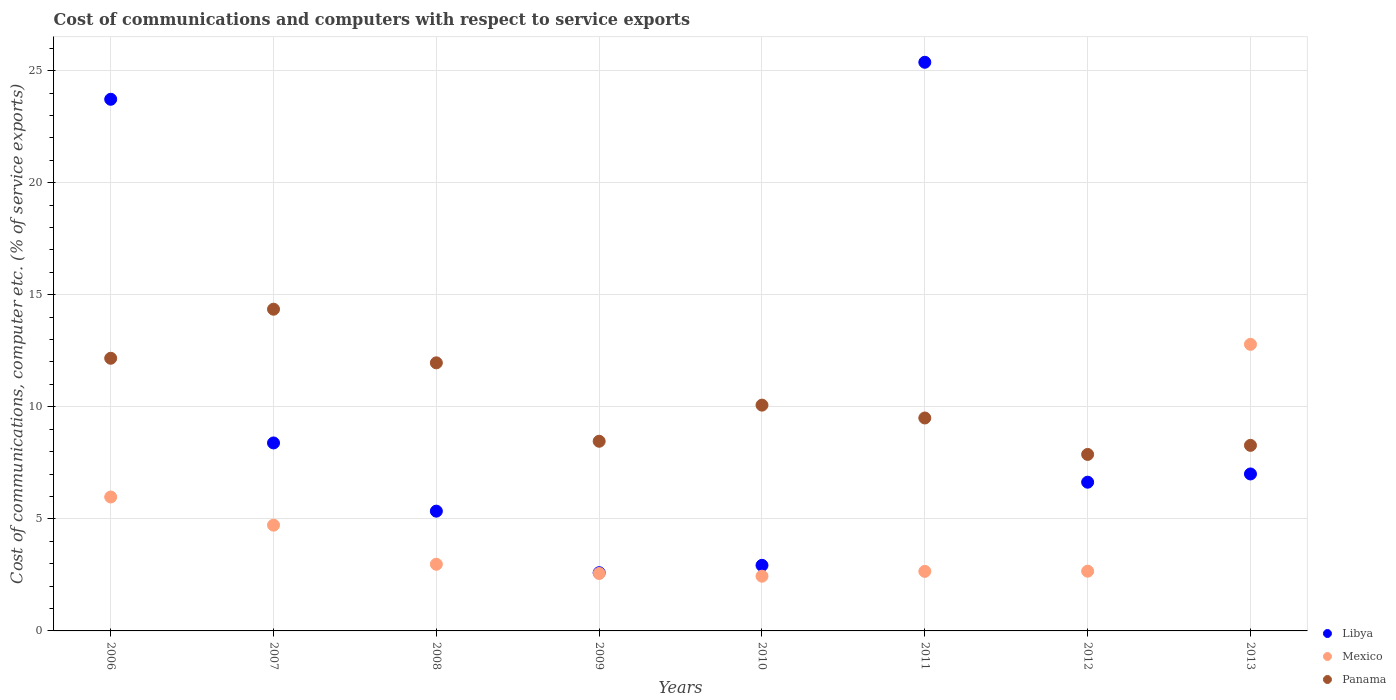Is the number of dotlines equal to the number of legend labels?
Offer a terse response. Yes. What is the cost of communications and computers in Libya in 2008?
Your answer should be compact. 5.34. Across all years, what is the maximum cost of communications and computers in Mexico?
Offer a terse response. 12.79. Across all years, what is the minimum cost of communications and computers in Mexico?
Offer a very short reply. 2.44. In which year was the cost of communications and computers in Libya maximum?
Ensure brevity in your answer.  2011. In which year was the cost of communications and computers in Libya minimum?
Provide a succinct answer. 2009. What is the total cost of communications and computers in Panama in the graph?
Make the answer very short. 82.68. What is the difference between the cost of communications and computers in Mexico in 2006 and that in 2013?
Give a very brief answer. -6.81. What is the difference between the cost of communications and computers in Mexico in 2011 and the cost of communications and computers in Panama in 2013?
Your answer should be compact. -5.62. What is the average cost of communications and computers in Libya per year?
Give a very brief answer. 10.25. In the year 2012, what is the difference between the cost of communications and computers in Mexico and cost of communications and computers in Libya?
Give a very brief answer. -3.97. What is the ratio of the cost of communications and computers in Mexico in 2009 to that in 2011?
Ensure brevity in your answer.  0.96. Is the cost of communications and computers in Mexico in 2010 less than that in 2013?
Your response must be concise. Yes. What is the difference between the highest and the second highest cost of communications and computers in Panama?
Your answer should be compact. 2.19. What is the difference between the highest and the lowest cost of communications and computers in Mexico?
Ensure brevity in your answer.  10.35. In how many years, is the cost of communications and computers in Libya greater than the average cost of communications and computers in Libya taken over all years?
Your answer should be compact. 2. Does the cost of communications and computers in Panama monotonically increase over the years?
Provide a succinct answer. No. Is the cost of communications and computers in Mexico strictly greater than the cost of communications and computers in Panama over the years?
Offer a terse response. No. Is the cost of communications and computers in Panama strictly less than the cost of communications and computers in Libya over the years?
Give a very brief answer. No. How many years are there in the graph?
Ensure brevity in your answer.  8. What is the difference between two consecutive major ticks on the Y-axis?
Offer a very short reply. 5. Are the values on the major ticks of Y-axis written in scientific E-notation?
Ensure brevity in your answer.  No. How many legend labels are there?
Your answer should be compact. 3. How are the legend labels stacked?
Provide a succinct answer. Vertical. What is the title of the graph?
Provide a short and direct response. Cost of communications and computers with respect to service exports. What is the label or title of the X-axis?
Your answer should be compact. Years. What is the label or title of the Y-axis?
Offer a terse response. Cost of communications, computer etc. (% of service exports). What is the Cost of communications, computer etc. (% of service exports) in Libya in 2006?
Ensure brevity in your answer.  23.72. What is the Cost of communications, computer etc. (% of service exports) of Mexico in 2006?
Give a very brief answer. 5.98. What is the Cost of communications, computer etc. (% of service exports) of Panama in 2006?
Your answer should be very brief. 12.17. What is the Cost of communications, computer etc. (% of service exports) in Libya in 2007?
Your response must be concise. 8.39. What is the Cost of communications, computer etc. (% of service exports) of Mexico in 2007?
Give a very brief answer. 4.72. What is the Cost of communications, computer etc. (% of service exports) of Panama in 2007?
Your response must be concise. 14.35. What is the Cost of communications, computer etc. (% of service exports) in Libya in 2008?
Provide a short and direct response. 5.34. What is the Cost of communications, computer etc. (% of service exports) of Mexico in 2008?
Offer a very short reply. 2.97. What is the Cost of communications, computer etc. (% of service exports) of Panama in 2008?
Offer a terse response. 11.96. What is the Cost of communications, computer etc. (% of service exports) of Libya in 2009?
Provide a short and direct response. 2.6. What is the Cost of communications, computer etc. (% of service exports) of Mexico in 2009?
Ensure brevity in your answer.  2.56. What is the Cost of communications, computer etc. (% of service exports) of Panama in 2009?
Your response must be concise. 8.46. What is the Cost of communications, computer etc. (% of service exports) of Libya in 2010?
Your response must be concise. 2.93. What is the Cost of communications, computer etc. (% of service exports) of Mexico in 2010?
Keep it short and to the point. 2.44. What is the Cost of communications, computer etc. (% of service exports) in Panama in 2010?
Your answer should be very brief. 10.07. What is the Cost of communications, computer etc. (% of service exports) of Libya in 2011?
Provide a succinct answer. 25.37. What is the Cost of communications, computer etc. (% of service exports) in Mexico in 2011?
Make the answer very short. 2.66. What is the Cost of communications, computer etc. (% of service exports) of Panama in 2011?
Make the answer very short. 9.5. What is the Cost of communications, computer etc. (% of service exports) in Libya in 2012?
Your answer should be very brief. 6.64. What is the Cost of communications, computer etc. (% of service exports) of Mexico in 2012?
Give a very brief answer. 2.67. What is the Cost of communications, computer etc. (% of service exports) of Panama in 2012?
Your answer should be compact. 7.87. What is the Cost of communications, computer etc. (% of service exports) in Libya in 2013?
Give a very brief answer. 7. What is the Cost of communications, computer etc. (% of service exports) of Mexico in 2013?
Your answer should be compact. 12.79. What is the Cost of communications, computer etc. (% of service exports) in Panama in 2013?
Give a very brief answer. 8.28. Across all years, what is the maximum Cost of communications, computer etc. (% of service exports) of Libya?
Your answer should be compact. 25.37. Across all years, what is the maximum Cost of communications, computer etc. (% of service exports) of Mexico?
Your answer should be very brief. 12.79. Across all years, what is the maximum Cost of communications, computer etc. (% of service exports) of Panama?
Provide a succinct answer. 14.35. Across all years, what is the minimum Cost of communications, computer etc. (% of service exports) of Libya?
Your answer should be very brief. 2.6. Across all years, what is the minimum Cost of communications, computer etc. (% of service exports) in Mexico?
Provide a succinct answer. 2.44. Across all years, what is the minimum Cost of communications, computer etc. (% of service exports) of Panama?
Offer a terse response. 7.87. What is the total Cost of communications, computer etc. (% of service exports) in Libya in the graph?
Your response must be concise. 81.99. What is the total Cost of communications, computer etc. (% of service exports) in Mexico in the graph?
Ensure brevity in your answer.  36.78. What is the total Cost of communications, computer etc. (% of service exports) of Panama in the graph?
Make the answer very short. 82.68. What is the difference between the Cost of communications, computer etc. (% of service exports) of Libya in 2006 and that in 2007?
Ensure brevity in your answer.  15.33. What is the difference between the Cost of communications, computer etc. (% of service exports) of Mexico in 2006 and that in 2007?
Provide a succinct answer. 1.26. What is the difference between the Cost of communications, computer etc. (% of service exports) of Panama in 2006 and that in 2007?
Offer a very short reply. -2.19. What is the difference between the Cost of communications, computer etc. (% of service exports) in Libya in 2006 and that in 2008?
Give a very brief answer. 18.38. What is the difference between the Cost of communications, computer etc. (% of service exports) of Mexico in 2006 and that in 2008?
Keep it short and to the point. 3. What is the difference between the Cost of communications, computer etc. (% of service exports) of Panama in 2006 and that in 2008?
Make the answer very short. 0.2. What is the difference between the Cost of communications, computer etc. (% of service exports) in Libya in 2006 and that in 2009?
Offer a very short reply. 21.12. What is the difference between the Cost of communications, computer etc. (% of service exports) of Mexico in 2006 and that in 2009?
Give a very brief answer. 3.41. What is the difference between the Cost of communications, computer etc. (% of service exports) of Panama in 2006 and that in 2009?
Provide a short and direct response. 3.7. What is the difference between the Cost of communications, computer etc. (% of service exports) of Libya in 2006 and that in 2010?
Provide a short and direct response. 20.8. What is the difference between the Cost of communications, computer etc. (% of service exports) in Mexico in 2006 and that in 2010?
Give a very brief answer. 3.53. What is the difference between the Cost of communications, computer etc. (% of service exports) in Panama in 2006 and that in 2010?
Your response must be concise. 2.09. What is the difference between the Cost of communications, computer etc. (% of service exports) in Libya in 2006 and that in 2011?
Your response must be concise. -1.65. What is the difference between the Cost of communications, computer etc. (% of service exports) in Mexico in 2006 and that in 2011?
Give a very brief answer. 3.32. What is the difference between the Cost of communications, computer etc. (% of service exports) in Panama in 2006 and that in 2011?
Offer a terse response. 2.66. What is the difference between the Cost of communications, computer etc. (% of service exports) in Libya in 2006 and that in 2012?
Ensure brevity in your answer.  17.09. What is the difference between the Cost of communications, computer etc. (% of service exports) of Mexico in 2006 and that in 2012?
Offer a terse response. 3.31. What is the difference between the Cost of communications, computer etc. (% of service exports) of Panama in 2006 and that in 2012?
Keep it short and to the point. 4.29. What is the difference between the Cost of communications, computer etc. (% of service exports) in Libya in 2006 and that in 2013?
Offer a terse response. 16.72. What is the difference between the Cost of communications, computer etc. (% of service exports) in Mexico in 2006 and that in 2013?
Ensure brevity in your answer.  -6.81. What is the difference between the Cost of communications, computer etc. (% of service exports) of Panama in 2006 and that in 2013?
Offer a terse response. 3.89. What is the difference between the Cost of communications, computer etc. (% of service exports) in Libya in 2007 and that in 2008?
Make the answer very short. 3.04. What is the difference between the Cost of communications, computer etc. (% of service exports) in Mexico in 2007 and that in 2008?
Provide a short and direct response. 1.75. What is the difference between the Cost of communications, computer etc. (% of service exports) of Panama in 2007 and that in 2008?
Provide a short and direct response. 2.39. What is the difference between the Cost of communications, computer etc. (% of service exports) of Libya in 2007 and that in 2009?
Provide a succinct answer. 5.79. What is the difference between the Cost of communications, computer etc. (% of service exports) of Mexico in 2007 and that in 2009?
Provide a succinct answer. 2.16. What is the difference between the Cost of communications, computer etc. (% of service exports) of Panama in 2007 and that in 2009?
Your response must be concise. 5.89. What is the difference between the Cost of communications, computer etc. (% of service exports) of Libya in 2007 and that in 2010?
Your response must be concise. 5.46. What is the difference between the Cost of communications, computer etc. (% of service exports) of Mexico in 2007 and that in 2010?
Provide a short and direct response. 2.28. What is the difference between the Cost of communications, computer etc. (% of service exports) in Panama in 2007 and that in 2010?
Provide a succinct answer. 4.28. What is the difference between the Cost of communications, computer etc. (% of service exports) of Libya in 2007 and that in 2011?
Provide a short and direct response. -16.99. What is the difference between the Cost of communications, computer etc. (% of service exports) in Mexico in 2007 and that in 2011?
Keep it short and to the point. 2.06. What is the difference between the Cost of communications, computer etc. (% of service exports) of Panama in 2007 and that in 2011?
Your answer should be very brief. 4.85. What is the difference between the Cost of communications, computer etc. (% of service exports) in Libya in 2007 and that in 2012?
Offer a terse response. 1.75. What is the difference between the Cost of communications, computer etc. (% of service exports) of Mexico in 2007 and that in 2012?
Offer a terse response. 2.05. What is the difference between the Cost of communications, computer etc. (% of service exports) of Panama in 2007 and that in 2012?
Provide a short and direct response. 6.48. What is the difference between the Cost of communications, computer etc. (% of service exports) of Libya in 2007 and that in 2013?
Keep it short and to the point. 1.38. What is the difference between the Cost of communications, computer etc. (% of service exports) of Mexico in 2007 and that in 2013?
Offer a very short reply. -8.07. What is the difference between the Cost of communications, computer etc. (% of service exports) in Panama in 2007 and that in 2013?
Ensure brevity in your answer.  6.07. What is the difference between the Cost of communications, computer etc. (% of service exports) in Libya in 2008 and that in 2009?
Your response must be concise. 2.75. What is the difference between the Cost of communications, computer etc. (% of service exports) in Mexico in 2008 and that in 2009?
Your response must be concise. 0.41. What is the difference between the Cost of communications, computer etc. (% of service exports) of Panama in 2008 and that in 2009?
Provide a succinct answer. 3.5. What is the difference between the Cost of communications, computer etc. (% of service exports) of Libya in 2008 and that in 2010?
Keep it short and to the point. 2.42. What is the difference between the Cost of communications, computer etc. (% of service exports) in Mexico in 2008 and that in 2010?
Make the answer very short. 0.53. What is the difference between the Cost of communications, computer etc. (% of service exports) in Panama in 2008 and that in 2010?
Make the answer very short. 1.89. What is the difference between the Cost of communications, computer etc. (% of service exports) of Libya in 2008 and that in 2011?
Your response must be concise. -20.03. What is the difference between the Cost of communications, computer etc. (% of service exports) of Mexico in 2008 and that in 2011?
Your answer should be compact. 0.32. What is the difference between the Cost of communications, computer etc. (% of service exports) of Panama in 2008 and that in 2011?
Provide a short and direct response. 2.46. What is the difference between the Cost of communications, computer etc. (% of service exports) of Libya in 2008 and that in 2012?
Your answer should be very brief. -1.29. What is the difference between the Cost of communications, computer etc. (% of service exports) in Mexico in 2008 and that in 2012?
Keep it short and to the point. 0.31. What is the difference between the Cost of communications, computer etc. (% of service exports) in Panama in 2008 and that in 2012?
Provide a succinct answer. 4.09. What is the difference between the Cost of communications, computer etc. (% of service exports) of Libya in 2008 and that in 2013?
Your response must be concise. -1.66. What is the difference between the Cost of communications, computer etc. (% of service exports) in Mexico in 2008 and that in 2013?
Your response must be concise. -9.81. What is the difference between the Cost of communications, computer etc. (% of service exports) in Panama in 2008 and that in 2013?
Provide a short and direct response. 3.68. What is the difference between the Cost of communications, computer etc. (% of service exports) in Libya in 2009 and that in 2010?
Your answer should be very brief. -0.33. What is the difference between the Cost of communications, computer etc. (% of service exports) in Mexico in 2009 and that in 2010?
Make the answer very short. 0.12. What is the difference between the Cost of communications, computer etc. (% of service exports) of Panama in 2009 and that in 2010?
Your answer should be compact. -1.61. What is the difference between the Cost of communications, computer etc. (% of service exports) in Libya in 2009 and that in 2011?
Provide a short and direct response. -22.78. What is the difference between the Cost of communications, computer etc. (% of service exports) of Mexico in 2009 and that in 2011?
Provide a succinct answer. -0.09. What is the difference between the Cost of communications, computer etc. (% of service exports) of Panama in 2009 and that in 2011?
Make the answer very short. -1.04. What is the difference between the Cost of communications, computer etc. (% of service exports) in Libya in 2009 and that in 2012?
Your answer should be very brief. -4.04. What is the difference between the Cost of communications, computer etc. (% of service exports) of Mexico in 2009 and that in 2012?
Your answer should be compact. -0.1. What is the difference between the Cost of communications, computer etc. (% of service exports) in Panama in 2009 and that in 2012?
Ensure brevity in your answer.  0.59. What is the difference between the Cost of communications, computer etc. (% of service exports) of Libya in 2009 and that in 2013?
Your answer should be compact. -4.41. What is the difference between the Cost of communications, computer etc. (% of service exports) of Mexico in 2009 and that in 2013?
Your response must be concise. -10.22. What is the difference between the Cost of communications, computer etc. (% of service exports) of Panama in 2009 and that in 2013?
Keep it short and to the point. 0.18. What is the difference between the Cost of communications, computer etc. (% of service exports) of Libya in 2010 and that in 2011?
Provide a short and direct response. -22.45. What is the difference between the Cost of communications, computer etc. (% of service exports) of Mexico in 2010 and that in 2011?
Provide a short and direct response. -0.22. What is the difference between the Cost of communications, computer etc. (% of service exports) of Panama in 2010 and that in 2011?
Provide a succinct answer. 0.57. What is the difference between the Cost of communications, computer etc. (% of service exports) of Libya in 2010 and that in 2012?
Give a very brief answer. -3.71. What is the difference between the Cost of communications, computer etc. (% of service exports) in Mexico in 2010 and that in 2012?
Keep it short and to the point. -0.22. What is the difference between the Cost of communications, computer etc. (% of service exports) in Panama in 2010 and that in 2012?
Offer a very short reply. 2.2. What is the difference between the Cost of communications, computer etc. (% of service exports) in Libya in 2010 and that in 2013?
Provide a short and direct response. -4.08. What is the difference between the Cost of communications, computer etc. (% of service exports) in Mexico in 2010 and that in 2013?
Offer a very short reply. -10.35. What is the difference between the Cost of communications, computer etc. (% of service exports) of Panama in 2010 and that in 2013?
Offer a terse response. 1.8. What is the difference between the Cost of communications, computer etc. (% of service exports) of Libya in 2011 and that in 2012?
Provide a succinct answer. 18.74. What is the difference between the Cost of communications, computer etc. (% of service exports) in Mexico in 2011 and that in 2012?
Give a very brief answer. -0.01. What is the difference between the Cost of communications, computer etc. (% of service exports) in Panama in 2011 and that in 2012?
Offer a terse response. 1.63. What is the difference between the Cost of communications, computer etc. (% of service exports) of Libya in 2011 and that in 2013?
Your answer should be very brief. 18.37. What is the difference between the Cost of communications, computer etc. (% of service exports) of Mexico in 2011 and that in 2013?
Provide a short and direct response. -10.13. What is the difference between the Cost of communications, computer etc. (% of service exports) of Panama in 2011 and that in 2013?
Your answer should be compact. 1.22. What is the difference between the Cost of communications, computer etc. (% of service exports) in Libya in 2012 and that in 2013?
Your answer should be compact. -0.37. What is the difference between the Cost of communications, computer etc. (% of service exports) of Mexico in 2012 and that in 2013?
Give a very brief answer. -10.12. What is the difference between the Cost of communications, computer etc. (% of service exports) in Panama in 2012 and that in 2013?
Provide a short and direct response. -0.4. What is the difference between the Cost of communications, computer etc. (% of service exports) of Libya in 2006 and the Cost of communications, computer etc. (% of service exports) of Mexico in 2007?
Give a very brief answer. 19. What is the difference between the Cost of communications, computer etc. (% of service exports) of Libya in 2006 and the Cost of communications, computer etc. (% of service exports) of Panama in 2007?
Give a very brief answer. 9.37. What is the difference between the Cost of communications, computer etc. (% of service exports) of Mexico in 2006 and the Cost of communications, computer etc. (% of service exports) of Panama in 2007?
Provide a succinct answer. -8.38. What is the difference between the Cost of communications, computer etc. (% of service exports) of Libya in 2006 and the Cost of communications, computer etc. (% of service exports) of Mexico in 2008?
Your answer should be very brief. 20.75. What is the difference between the Cost of communications, computer etc. (% of service exports) of Libya in 2006 and the Cost of communications, computer etc. (% of service exports) of Panama in 2008?
Offer a terse response. 11.76. What is the difference between the Cost of communications, computer etc. (% of service exports) of Mexico in 2006 and the Cost of communications, computer etc. (% of service exports) of Panama in 2008?
Give a very brief answer. -5.99. What is the difference between the Cost of communications, computer etc. (% of service exports) of Libya in 2006 and the Cost of communications, computer etc. (% of service exports) of Mexico in 2009?
Offer a very short reply. 21.16. What is the difference between the Cost of communications, computer etc. (% of service exports) of Libya in 2006 and the Cost of communications, computer etc. (% of service exports) of Panama in 2009?
Your answer should be very brief. 15.26. What is the difference between the Cost of communications, computer etc. (% of service exports) in Mexico in 2006 and the Cost of communications, computer etc. (% of service exports) in Panama in 2009?
Provide a short and direct response. -2.49. What is the difference between the Cost of communications, computer etc. (% of service exports) of Libya in 2006 and the Cost of communications, computer etc. (% of service exports) of Mexico in 2010?
Offer a terse response. 21.28. What is the difference between the Cost of communications, computer etc. (% of service exports) in Libya in 2006 and the Cost of communications, computer etc. (% of service exports) in Panama in 2010?
Offer a very short reply. 13.65. What is the difference between the Cost of communications, computer etc. (% of service exports) in Mexico in 2006 and the Cost of communications, computer etc. (% of service exports) in Panama in 2010?
Offer a terse response. -4.1. What is the difference between the Cost of communications, computer etc. (% of service exports) of Libya in 2006 and the Cost of communications, computer etc. (% of service exports) of Mexico in 2011?
Offer a very short reply. 21.06. What is the difference between the Cost of communications, computer etc. (% of service exports) in Libya in 2006 and the Cost of communications, computer etc. (% of service exports) in Panama in 2011?
Provide a short and direct response. 14.22. What is the difference between the Cost of communications, computer etc. (% of service exports) of Mexico in 2006 and the Cost of communications, computer etc. (% of service exports) of Panama in 2011?
Provide a succinct answer. -3.53. What is the difference between the Cost of communications, computer etc. (% of service exports) in Libya in 2006 and the Cost of communications, computer etc. (% of service exports) in Mexico in 2012?
Your response must be concise. 21.06. What is the difference between the Cost of communications, computer etc. (% of service exports) of Libya in 2006 and the Cost of communications, computer etc. (% of service exports) of Panama in 2012?
Offer a terse response. 15.85. What is the difference between the Cost of communications, computer etc. (% of service exports) of Mexico in 2006 and the Cost of communications, computer etc. (% of service exports) of Panama in 2012?
Ensure brevity in your answer.  -1.9. What is the difference between the Cost of communications, computer etc. (% of service exports) of Libya in 2006 and the Cost of communications, computer etc. (% of service exports) of Mexico in 2013?
Provide a short and direct response. 10.93. What is the difference between the Cost of communications, computer etc. (% of service exports) in Libya in 2006 and the Cost of communications, computer etc. (% of service exports) in Panama in 2013?
Provide a short and direct response. 15.44. What is the difference between the Cost of communications, computer etc. (% of service exports) in Mexico in 2006 and the Cost of communications, computer etc. (% of service exports) in Panama in 2013?
Your answer should be compact. -2.3. What is the difference between the Cost of communications, computer etc. (% of service exports) in Libya in 2007 and the Cost of communications, computer etc. (% of service exports) in Mexico in 2008?
Offer a very short reply. 5.41. What is the difference between the Cost of communications, computer etc. (% of service exports) of Libya in 2007 and the Cost of communications, computer etc. (% of service exports) of Panama in 2008?
Keep it short and to the point. -3.58. What is the difference between the Cost of communications, computer etc. (% of service exports) of Mexico in 2007 and the Cost of communications, computer etc. (% of service exports) of Panama in 2008?
Offer a very short reply. -7.24. What is the difference between the Cost of communications, computer etc. (% of service exports) of Libya in 2007 and the Cost of communications, computer etc. (% of service exports) of Mexico in 2009?
Provide a succinct answer. 5.82. What is the difference between the Cost of communications, computer etc. (% of service exports) of Libya in 2007 and the Cost of communications, computer etc. (% of service exports) of Panama in 2009?
Your response must be concise. -0.08. What is the difference between the Cost of communications, computer etc. (% of service exports) in Mexico in 2007 and the Cost of communications, computer etc. (% of service exports) in Panama in 2009?
Offer a terse response. -3.74. What is the difference between the Cost of communications, computer etc. (% of service exports) of Libya in 2007 and the Cost of communications, computer etc. (% of service exports) of Mexico in 2010?
Offer a very short reply. 5.95. What is the difference between the Cost of communications, computer etc. (% of service exports) of Libya in 2007 and the Cost of communications, computer etc. (% of service exports) of Panama in 2010?
Make the answer very short. -1.69. What is the difference between the Cost of communications, computer etc. (% of service exports) of Mexico in 2007 and the Cost of communications, computer etc. (% of service exports) of Panama in 2010?
Give a very brief answer. -5.36. What is the difference between the Cost of communications, computer etc. (% of service exports) in Libya in 2007 and the Cost of communications, computer etc. (% of service exports) in Mexico in 2011?
Your response must be concise. 5.73. What is the difference between the Cost of communications, computer etc. (% of service exports) of Libya in 2007 and the Cost of communications, computer etc. (% of service exports) of Panama in 2011?
Make the answer very short. -1.11. What is the difference between the Cost of communications, computer etc. (% of service exports) in Mexico in 2007 and the Cost of communications, computer etc. (% of service exports) in Panama in 2011?
Keep it short and to the point. -4.78. What is the difference between the Cost of communications, computer etc. (% of service exports) of Libya in 2007 and the Cost of communications, computer etc. (% of service exports) of Mexico in 2012?
Your answer should be very brief. 5.72. What is the difference between the Cost of communications, computer etc. (% of service exports) of Libya in 2007 and the Cost of communications, computer etc. (% of service exports) of Panama in 2012?
Offer a very short reply. 0.51. What is the difference between the Cost of communications, computer etc. (% of service exports) of Mexico in 2007 and the Cost of communications, computer etc. (% of service exports) of Panama in 2012?
Offer a very short reply. -3.16. What is the difference between the Cost of communications, computer etc. (% of service exports) of Libya in 2007 and the Cost of communications, computer etc. (% of service exports) of Mexico in 2013?
Keep it short and to the point. -4.4. What is the difference between the Cost of communications, computer etc. (% of service exports) of Libya in 2007 and the Cost of communications, computer etc. (% of service exports) of Panama in 2013?
Ensure brevity in your answer.  0.11. What is the difference between the Cost of communications, computer etc. (% of service exports) of Mexico in 2007 and the Cost of communications, computer etc. (% of service exports) of Panama in 2013?
Ensure brevity in your answer.  -3.56. What is the difference between the Cost of communications, computer etc. (% of service exports) of Libya in 2008 and the Cost of communications, computer etc. (% of service exports) of Mexico in 2009?
Give a very brief answer. 2.78. What is the difference between the Cost of communications, computer etc. (% of service exports) in Libya in 2008 and the Cost of communications, computer etc. (% of service exports) in Panama in 2009?
Provide a short and direct response. -3.12. What is the difference between the Cost of communications, computer etc. (% of service exports) of Mexico in 2008 and the Cost of communications, computer etc. (% of service exports) of Panama in 2009?
Offer a very short reply. -5.49. What is the difference between the Cost of communications, computer etc. (% of service exports) of Libya in 2008 and the Cost of communications, computer etc. (% of service exports) of Mexico in 2010?
Keep it short and to the point. 2.9. What is the difference between the Cost of communications, computer etc. (% of service exports) in Libya in 2008 and the Cost of communications, computer etc. (% of service exports) in Panama in 2010?
Your answer should be compact. -4.73. What is the difference between the Cost of communications, computer etc. (% of service exports) of Mexico in 2008 and the Cost of communications, computer etc. (% of service exports) of Panama in 2010?
Give a very brief answer. -7.1. What is the difference between the Cost of communications, computer etc. (% of service exports) of Libya in 2008 and the Cost of communications, computer etc. (% of service exports) of Mexico in 2011?
Offer a very short reply. 2.69. What is the difference between the Cost of communications, computer etc. (% of service exports) of Libya in 2008 and the Cost of communications, computer etc. (% of service exports) of Panama in 2011?
Keep it short and to the point. -4.16. What is the difference between the Cost of communications, computer etc. (% of service exports) of Mexico in 2008 and the Cost of communications, computer etc. (% of service exports) of Panama in 2011?
Provide a succinct answer. -6.53. What is the difference between the Cost of communications, computer etc. (% of service exports) in Libya in 2008 and the Cost of communications, computer etc. (% of service exports) in Mexico in 2012?
Make the answer very short. 2.68. What is the difference between the Cost of communications, computer etc. (% of service exports) of Libya in 2008 and the Cost of communications, computer etc. (% of service exports) of Panama in 2012?
Provide a succinct answer. -2.53. What is the difference between the Cost of communications, computer etc. (% of service exports) in Mexico in 2008 and the Cost of communications, computer etc. (% of service exports) in Panama in 2012?
Your answer should be very brief. -4.9. What is the difference between the Cost of communications, computer etc. (% of service exports) in Libya in 2008 and the Cost of communications, computer etc. (% of service exports) in Mexico in 2013?
Provide a succinct answer. -7.44. What is the difference between the Cost of communications, computer etc. (% of service exports) of Libya in 2008 and the Cost of communications, computer etc. (% of service exports) of Panama in 2013?
Your answer should be compact. -2.94. What is the difference between the Cost of communications, computer etc. (% of service exports) of Mexico in 2008 and the Cost of communications, computer etc. (% of service exports) of Panama in 2013?
Your response must be concise. -5.31. What is the difference between the Cost of communications, computer etc. (% of service exports) of Libya in 2009 and the Cost of communications, computer etc. (% of service exports) of Mexico in 2010?
Provide a short and direct response. 0.16. What is the difference between the Cost of communications, computer etc. (% of service exports) of Libya in 2009 and the Cost of communications, computer etc. (% of service exports) of Panama in 2010?
Offer a terse response. -7.48. What is the difference between the Cost of communications, computer etc. (% of service exports) of Mexico in 2009 and the Cost of communications, computer etc. (% of service exports) of Panama in 2010?
Provide a succinct answer. -7.51. What is the difference between the Cost of communications, computer etc. (% of service exports) of Libya in 2009 and the Cost of communications, computer etc. (% of service exports) of Mexico in 2011?
Provide a succinct answer. -0.06. What is the difference between the Cost of communications, computer etc. (% of service exports) of Libya in 2009 and the Cost of communications, computer etc. (% of service exports) of Panama in 2011?
Offer a terse response. -6.9. What is the difference between the Cost of communications, computer etc. (% of service exports) of Mexico in 2009 and the Cost of communications, computer etc. (% of service exports) of Panama in 2011?
Provide a short and direct response. -6.94. What is the difference between the Cost of communications, computer etc. (% of service exports) of Libya in 2009 and the Cost of communications, computer etc. (% of service exports) of Mexico in 2012?
Provide a succinct answer. -0.07. What is the difference between the Cost of communications, computer etc. (% of service exports) in Libya in 2009 and the Cost of communications, computer etc. (% of service exports) in Panama in 2012?
Your answer should be compact. -5.28. What is the difference between the Cost of communications, computer etc. (% of service exports) of Mexico in 2009 and the Cost of communications, computer etc. (% of service exports) of Panama in 2012?
Your response must be concise. -5.31. What is the difference between the Cost of communications, computer etc. (% of service exports) in Libya in 2009 and the Cost of communications, computer etc. (% of service exports) in Mexico in 2013?
Provide a succinct answer. -10.19. What is the difference between the Cost of communications, computer etc. (% of service exports) of Libya in 2009 and the Cost of communications, computer etc. (% of service exports) of Panama in 2013?
Make the answer very short. -5.68. What is the difference between the Cost of communications, computer etc. (% of service exports) of Mexico in 2009 and the Cost of communications, computer etc. (% of service exports) of Panama in 2013?
Give a very brief answer. -5.72. What is the difference between the Cost of communications, computer etc. (% of service exports) in Libya in 2010 and the Cost of communications, computer etc. (% of service exports) in Mexico in 2011?
Give a very brief answer. 0.27. What is the difference between the Cost of communications, computer etc. (% of service exports) of Libya in 2010 and the Cost of communications, computer etc. (% of service exports) of Panama in 2011?
Keep it short and to the point. -6.58. What is the difference between the Cost of communications, computer etc. (% of service exports) in Mexico in 2010 and the Cost of communications, computer etc. (% of service exports) in Panama in 2011?
Offer a very short reply. -7.06. What is the difference between the Cost of communications, computer etc. (% of service exports) in Libya in 2010 and the Cost of communications, computer etc. (% of service exports) in Mexico in 2012?
Keep it short and to the point. 0.26. What is the difference between the Cost of communications, computer etc. (% of service exports) of Libya in 2010 and the Cost of communications, computer etc. (% of service exports) of Panama in 2012?
Make the answer very short. -4.95. What is the difference between the Cost of communications, computer etc. (% of service exports) of Mexico in 2010 and the Cost of communications, computer etc. (% of service exports) of Panama in 2012?
Offer a very short reply. -5.43. What is the difference between the Cost of communications, computer etc. (% of service exports) in Libya in 2010 and the Cost of communications, computer etc. (% of service exports) in Mexico in 2013?
Your answer should be compact. -9.86. What is the difference between the Cost of communications, computer etc. (% of service exports) of Libya in 2010 and the Cost of communications, computer etc. (% of service exports) of Panama in 2013?
Ensure brevity in your answer.  -5.35. What is the difference between the Cost of communications, computer etc. (% of service exports) in Mexico in 2010 and the Cost of communications, computer etc. (% of service exports) in Panama in 2013?
Offer a terse response. -5.84. What is the difference between the Cost of communications, computer etc. (% of service exports) of Libya in 2011 and the Cost of communications, computer etc. (% of service exports) of Mexico in 2012?
Offer a very short reply. 22.71. What is the difference between the Cost of communications, computer etc. (% of service exports) of Libya in 2011 and the Cost of communications, computer etc. (% of service exports) of Panama in 2012?
Provide a short and direct response. 17.5. What is the difference between the Cost of communications, computer etc. (% of service exports) in Mexico in 2011 and the Cost of communications, computer etc. (% of service exports) in Panama in 2012?
Give a very brief answer. -5.22. What is the difference between the Cost of communications, computer etc. (% of service exports) of Libya in 2011 and the Cost of communications, computer etc. (% of service exports) of Mexico in 2013?
Ensure brevity in your answer.  12.59. What is the difference between the Cost of communications, computer etc. (% of service exports) in Libya in 2011 and the Cost of communications, computer etc. (% of service exports) in Panama in 2013?
Offer a very short reply. 17.09. What is the difference between the Cost of communications, computer etc. (% of service exports) of Mexico in 2011 and the Cost of communications, computer etc. (% of service exports) of Panama in 2013?
Keep it short and to the point. -5.62. What is the difference between the Cost of communications, computer etc. (% of service exports) in Libya in 2012 and the Cost of communications, computer etc. (% of service exports) in Mexico in 2013?
Provide a succinct answer. -6.15. What is the difference between the Cost of communications, computer etc. (% of service exports) of Libya in 2012 and the Cost of communications, computer etc. (% of service exports) of Panama in 2013?
Your answer should be compact. -1.64. What is the difference between the Cost of communications, computer etc. (% of service exports) in Mexico in 2012 and the Cost of communications, computer etc. (% of service exports) in Panama in 2013?
Offer a very short reply. -5.61. What is the average Cost of communications, computer etc. (% of service exports) in Libya per year?
Your response must be concise. 10.25. What is the average Cost of communications, computer etc. (% of service exports) in Mexico per year?
Your answer should be compact. 4.6. What is the average Cost of communications, computer etc. (% of service exports) of Panama per year?
Your response must be concise. 10.33. In the year 2006, what is the difference between the Cost of communications, computer etc. (% of service exports) of Libya and Cost of communications, computer etc. (% of service exports) of Mexico?
Offer a terse response. 17.75. In the year 2006, what is the difference between the Cost of communications, computer etc. (% of service exports) of Libya and Cost of communications, computer etc. (% of service exports) of Panama?
Make the answer very short. 11.56. In the year 2006, what is the difference between the Cost of communications, computer etc. (% of service exports) in Mexico and Cost of communications, computer etc. (% of service exports) in Panama?
Offer a terse response. -6.19. In the year 2007, what is the difference between the Cost of communications, computer etc. (% of service exports) in Libya and Cost of communications, computer etc. (% of service exports) in Mexico?
Offer a very short reply. 3.67. In the year 2007, what is the difference between the Cost of communications, computer etc. (% of service exports) in Libya and Cost of communications, computer etc. (% of service exports) in Panama?
Offer a terse response. -5.97. In the year 2007, what is the difference between the Cost of communications, computer etc. (% of service exports) in Mexico and Cost of communications, computer etc. (% of service exports) in Panama?
Make the answer very short. -9.63. In the year 2008, what is the difference between the Cost of communications, computer etc. (% of service exports) of Libya and Cost of communications, computer etc. (% of service exports) of Mexico?
Make the answer very short. 2.37. In the year 2008, what is the difference between the Cost of communications, computer etc. (% of service exports) of Libya and Cost of communications, computer etc. (% of service exports) of Panama?
Give a very brief answer. -6.62. In the year 2008, what is the difference between the Cost of communications, computer etc. (% of service exports) in Mexico and Cost of communications, computer etc. (% of service exports) in Panama?
Make the answer very short. -8.99. In the year 2009, what is the difference between the Cost of communications, computer etc. (% of service exports) in Libya and Cost of communications, computer etc. (% of service exports) in Mexico?
Your response must be concise. 0.03. In the year 2009, what is the difference between the Cost of communications, computer etc. (% of service exports) in Libya and Cost of communications, computer etc. (% of service exports) in Panama?
Your answer should be very brief. -5.87. In the year 2009, what is the difference between the Cost of communications, computer etc. (% of service exports) in Mexico and Cost of communications, computer etc. (% of service exports) in Panama?
Offer a terse response. -5.9. In the year 2010, what is the difference between the Cost of communications, computer etc. (% of service exports) of Libya and Cost of communications, computer etc. (% of service exports) of Mexico?
Ensure brevity in your answer.  0.48. In the year 2010, what is the difference between the Cost of communications, computer etc. (% of service exports) in Libya and Cost of communications, computer etc. (% of service exports) in Panama?
Your response must be concise. -7.15. In the year 2010, what is the difference between the Cost of communications, computer etc. (% of service exports) in Mexico and Cost of communications, computer etc. (% of service exports) in Panama?
Make the answer very short. -7.63. In the year 2011, what is the difference between the Cost of communications, computer etc. (% of service exports) of Libya and Cost of communications, computer etc. (% of service exports) of Mexico?
Provide a short and direct response. 22.72. In the year 2011, what is the difference between the Cost of communications, computer etc. (% of service exports) of Libya and Cost of communications, computer etc. (% of service exports) of Panama?
Offer a very short reply. 15.87. In the year 2011, what is the difference between the Cost of communications, computer etc. (% of service exports) in Mexico and Cost of communications, computer etc. (% of service exports) in Panama?
Offer a very short reply. -6.84. In the year 2012, what is the difference between the Cost of communications, computer etc. (% of service exports) of Libya and Cost of communications, computer etc. (% of service exports) of Mexico?
Offer a terse response. 3.97. In the year 2012, what is the difference between the Cost of communications, computer etc. (% of service exports) of Libya and Cost of communications, computer etc. (% of service exports) of Panama?
Offer a terse response. -1.24. In the year 2012, what is the difference between the Cost of communications, computer etc. (% of service exports) in Mexico and Cost of communications, computer etc. (% of service exports) in Panama?
Provide a short and direct response. -5.21. In the year 2013, what is the difference between the Cost of communications, computer etc. (% of service exports) of Libya and Cost of communications, computer etc. (% of service exports) of Mexico?
Provide a short and direct response. -5.78. In the year 2013, what is the difference between the Cost of communications, computer etc. (% of service exports) in Libya and Cost of communications, computer etc. (% of service exports) in Panama?
Provide a succinct answer. -1.28. In the year 2013, what is the difference between the Cost of communications, computer etc. (% of service exports) of Mexico and Cost of communications, computer etc. (% of service exports) of Panama?
Your answer should be very brief. 4.51. What is the ratio of the Cost of communications, computer etc. (% of service exports) in Libya in 2006 to that in 2007?
Keep it short and to the point. 2.83. What is the ratio of the Cost of communications, computer etc. (% of service exports) of Mexico in 2006 to that in 2007?
Give a very brief answer. 1.27. What is the ratio of the Cost of communications, computer etc. (% of service exports) in Panama in 2006 to that in 2007?
Make the answer very short. 0.85. What is the ratio of the Cost of communications, computer etc. (% of service exports) in Libya in 2006 to that in 2008?
Give a very brief answer. 4.44. What is the ratio of the Cost of communications, computer etc. (% of service exports) of Mexico in 2006 to that in 2008?
Your response must be concise. 2.01. What is the ratio of the Cost of communications, computer etc. (% of service exports) in Panama in 2006 to that in 2008?
Offer a very short reply. 1.02. What is the ratio of the Cost of communications, computer etc. (% of service exports) of Libya in 2006 to that in 2009?
Give a very brief answer. 9.13. What is the ratio of the Cost of communications, computer etc. (% of service exports) of Mexico in 2006 to that in 2009?
Offer a very short reply. 2.33. What is the ratio of the Cost of communications, computer etc. (% of service exports) of Panama in 2006 to that in 2009?
Ensure brevity in your answer.  1.44. What is the ratio of the Cost of communications, computer etc. (% of service exports) in Libya in 2006 to that in 2010?
Give a very brief answer. 8.11. What is the ratio of the Cost of communications, computer etc. (% of service exports) in Mexico in 2006 to that in 2010?
Your response must be concise. 2.45. What is the ratio of the Cost of communications, computer etc. (% of service exports) of Panama in 2006 to that in 2010?
Your answer should be compact. 1.21. What is the ratio of the Cost of communications, computer etc. (% of service exports) of Libya in 2006 to that in 2011?
Your response must be concise. 0.93. What is the ratio of the Cost of communications, computer etc. (% of service exports) of Mexico in 2006 to that in 2011?
Your answer should be compact. 2.25. What is the ratio of the Cost of communications, computer etc. (% of service exports) of Panama in 2006 to that in 2011?
Make the answer very short. 1.28. What is the ratio of the Cost of communications, computer etc. (% of service exports) of Libya in 2006 to that in 2012?
Keep it short and to the point. 3.57. What is the ratio of the Cost of communications, computer etc. (% of service exports) of Mexico in 2006 to that in 2012?
Offer a very short reply. 2.24. What is the ratio of the Cost of communications, computer etc. (% of service exports) in Panama in 2006 to that in 2012?
Provide a succinct answer. 1.54. What is the ratio of the Cost of communications, computer etc. (% of service exports) of Libya in 2006 to that in 2013?
Ensure brevity in your answer.  3.39. What is the ratio of the Cost of communications, computer etc. (% of service exports) in Mexico in 2006 to that in 2013?
Your answer should be very brief. 0.47. What is the ratio of the Cost of communications, computer etc. (% of service exports) of Panama in 2006 to that in 2013?
Make the answer very short. 1.47. What is the ratio of the Cost of communications, computer etc. (% of service exports) in Libya in 2007 to that in 2008?
Provide a short and direct response. 1.57. What is the ratio of the Cost of communications, computer etc. (% of service exports) of Mexico in 2007 to that in 2008?
Offer a terse response. 1.59. What is the ratio of the Cost of communications, computer etc. (% of service exports) in Libya in 2007 to that in 2009?
Give a very brief answer. 3.23. What is the ratio of the Cost of communications, computer etc. (% of service exports) of Mexico in 2007 to that in 2009?
Ensure brevity in your answer.  1.84. What is the ratio of the Cost of communications, computer etc. (% of service exports) of Panama in 2007 to that in 2009?
Provide a succinct answer. 1.7. What is the ratio of the Cost of communications, computer etc. (% of service exports) of Libya in 2007 to that in 2010?
Offer a terse response. 2.87. What is the ratio of the Cost of communications, computer etc. (% of service exports) of Mexico in 2007 to that in 2010?
Offer a very short reply. 1.93. What is the ratio of the Cost of communications, computer etc. (% of service exports) in Panama in 2007 to that in 2010?
Your answer should be compact. 1.42. What is the ratio of the Cost of communications, computer etc. (% of service exports) of Libya in 2007 to that in 2011?
Offer a terse response. 0.33. What is the ratio of the Cost of communications, computer etc. (% of service exports) of Mexico in 2007 to that in 2011?
Ensure brevity in your answer.  1.78. What is the ratio of the Cost of communications, computer etc. (% of service exports) of Panama in 2007 to that in 2011?
Your answer should be very brief. 1.51. What is the ratio of the Cost of communications, computer etc. (% of service exports) in Libya in 2007 to that in 2012?
Provide a succinct answer. 1.26. What is the ratio of the Cost of communications, computer etc. (% of service exports) of Mexico in 2007 to that in 2012?
Your answer should be compact. 1.77. What is the ratio of the Cost of communications, computer etc. (% of service exports) of Panama in 2007 to that in 2012?
Offer a very short reply. 1.82. What is the ratio of the Cost of communications, computer etc. (% of service exports) in Libya in 2007 to that in 2013?
Give a very brief answer. 1.2. What is the ratio of the Cost of communications, computer etc. (% of service exports) of Mexico in 2007 to that in 2013?
Your answer should be very brief. 0.37. What is the ratio of the Cost of communications, computer etc. (% of service exports) in Panama in 2007 to that in 2013?
Offer a very short reply. 1.73. What is the ratio of the Cost of communications, computer etc. (% of service exports) of Libya in 2008 to that in 2009?
Provide a succinct answer. 2.06. What is the ratio of the Cost of communications, computer etc. (% of service exports) in Mexico in 2008 to that in 2009?
Keep it short and to the point. 1.16. What is the ratio of the Cost of communications, computer etc. (% of service exports) in Panama in 2008 to that in 2009?
Offer a terse response. 1.41. What is the ratio of the Cost of communications, computer etc. (% of service exports) in Libya in 2008 to that in 2010?
Your response must be concise. 1.83. What is the ratio of the Cost of communications, computer etc. (% of service exports) in Mexico in 2008 to that in 2010?
Keep it short and to the point. 1.22. What is the ratio of the Cost of communications, computer etc. (% of service exports) in Panama in 2008 to that in 2010?
Offer a very short reply. 1.19. What is the ratio of the Cost of communications, computer etc. (% of service exports) of Libya in 2008 to that in 2011?
Your response must be concise. 0.21. What is the ratio of the Cost of communications, computer etc. (% of service exports) of Mexico in 2008 to that in 2011?
Your response must be concise. 1.12. What is the ratio of the Cost of communications, computer etc. (% of service exports) in Panama in 2008 to that in 2011?
Ensure brevity in your answer.  1.26. What is the ratio of the Cost of communications, computer etc. (% of service exports) of Libya in 2008 to that in 2012?
Provide a succinct answer. 0.81. What is the ratio of the Cost of communications, computer etc. (% of service exports) of Mexico in 2008 to that in 2012?
Give a very brief answer. 1.12. What is the ratio of the Cost of communications, computer etc. (% of service exports) in Panama in 2008 to that in 2012?
Provide a succinct answer. 1.52. What is the ratio of the Cost of communications, computer etc. (% of service exports) of Libya in 2008 to that in 2013?
Offer a very short reply. 0.76. What is the ratio of the Cost of communications, computer etc. (% of service exports) of Mexico in 2008 to that in 2013?
Your response must be concise. 0.23. What is the ratio of the Cost of communications, computer etc. (% of service exports) in Panama in 2008 to that in 2013?
Make the answer very short. 1.44. What is the ratio of the Cost of communications, computer etc. (% of service exports) in Libya in 2009 to that in 2010?
Your answer should be compact. 0.89. What is the ratio of the Cost of communications, computer etc. (% of service exports) in Mexico in 2009 to that in 2010?
Ensure brevity in your answer.  1.05. What is the ratio of the Cost of communications, computer etc. (% of service exports) in Panama in 2009 to that in 2010?
Your response must be concise. 0.84. What is the ratio of the Cost of communications, computer etc. (% of service exports) in Libya in 2009 to that in 2011?
Your response must be concise. 0.1. What is the ratio of the Cost of communications, computer etc. (% of service exports) in Mexico in 2009 to that in 2011?
Offer a terse response. 0.96. What is the ratio of the Cost of communications, computer etc. (% of service exports) of Panama in 2009 to that in 2011?
Your answer should be compact. 0.89. What is the ratio of the Cost of communications, computer etc. (% of service exports) of Libya in 2009 to that in 2012?
Provide a succinct answer. 0.39. What is the ratio of the Cost of communications, computer etc. (% of service exports) of Mexico in 2009 to that in 2012?
Keep it short and to the point. 0.96. What is the ratio of the Cost of communications, computer etc. (% of service exports) in Panama in 2009 to that in 2012?
Your answer should be very brief. 1.07. What is the ratio of the Cost of communications, computer etc. (% of service exports) of Libya in 2009 to that in 2013?
Offer a terse response. 0.37. What is the ratio of the Cost of communications, computer etc. (% of service exports) of Mexico in 2009 to that in 2013?
Your answer should be compact. 0.2. What is the ratio of the Cost of communications, computer etc. (% of service exports) in Panama in 2009 to that in 2013?
Give a very brief answer. 1.02. What is the ratio of the Cost of communications, computer etc. (% of service exports) in Libya in 2010 to that in 2011?
Your response must be concise. 0.12. What is the ratio of the Cost of communications, computer etc. (% of service exports) of Mexico in 2010 to that in 2011?
Give a very brief answer. 0.92. What is the ratio of the Cost of communications, computer etc. (% of service exports) of Panama in 2010 to that in 2011?
Offer a very short reply. 1.06. What is the ratio of the Cost of communications, computer etc. (% of service exports) of Libya in 2010 to that in 2012?
Give a very brief answer. 0.44. What is the ratio of the Cost of communications, computer etc. (% of service exports) in Mexico in 2010 to that in 2012?
Make the answer very short. 0.92. What is the ratio of the Cost of communications, computer etc. (% of service exports) of Panama in 2010 to that in 2012?
Your response must be concise. 1.28. What is the ratio of the Cost of communications, computer etc. (% of service exports) in Libya in 2010 to that in 2013?
Ensure brevity in your answer.  0.42. What is the ratio of the Cost of communications, computer etc. (% of service exports) in Mexico in 2010 to that in 2013?
Offer a very short reply. 0.19. What is the ratio of the Cost of communications, computer etc. (% of service exports) in Panama in 2010 to that in 2013?
Provide a succinct answer. 1.22. What is the ratio of the Cost of communications, computer etc. (% of service exports) in Libya in 2011 to that in 2012?
Offer a terse response. 3.82. What is the ratio of the Cost of communications, computer etc. (% of service exports) in Mexico in 2011 to that in 2012?
Ensure brevity in your answer.  1. What is the ratio of the Cost of communications, computer etc. (% of service exports) in Panama in 2011 to that in 2012?
Provide a succinct answer. 1.21. What is the ratio of the Cost of communications, computer etc. (% of service exports) in Libya in 2011 to that in 2013?
Make the answer very short. 3.62. What is the ratio of the Cost of communications, computer etc. (% of service exports) of Mexico in 2011 to that in 2013?
Ensure brevity in your answer.  0.21. What is the ratio of the Cost of communications, computer etc. (% of service exports) in Panama in 2011 to that in 2013?
Your answer should be very brief. 1.15. What is the ratio of the Cost of communications, computer etc. (% of service exports) of Libya in 2012 to that in 2013?
Provide a succinct answer. 0.95. What is the ratio of the Cost of communications, computer etc. (% of service exports) in Mexico in 2012 to that in 2013?
Your answer should be compact. 0.21. What is the ratio of the Cost of communications, computer etc. (% of service exports) of Panama in 2012 to that in 2013?
Your response must be concise. 0.95. What is the difference between the highest and the second highest Cost of communications, computer etc. (% of service exports) in Libya?
Keep it short and to the point. 1.65. What is the difference between the highest and the second highest Cost of communications, computer etc. (% of service exports) in Mexico?
Offer a very short reply. 6.81. What is the difference between the highest and the second highest Cost of communications, computer etc. (% of service exports) in Panama?
Your answer should be very brief. 2.19. What is the difference between the highest and the lowest Cost of communications, computer etc. (% of service exports) of Libya?
Provide a succinct answer. 22.78. What is the difference between the highest and the lowest Cost of communications, computer etc. (% of service exports) of Mexico?
Give a very brief answer. 10.35. What is the difference between the highest and the lowest Cost of communications, computer etc. (% of service exports) in Panama?
Provide a succinct answer. 6.48. 